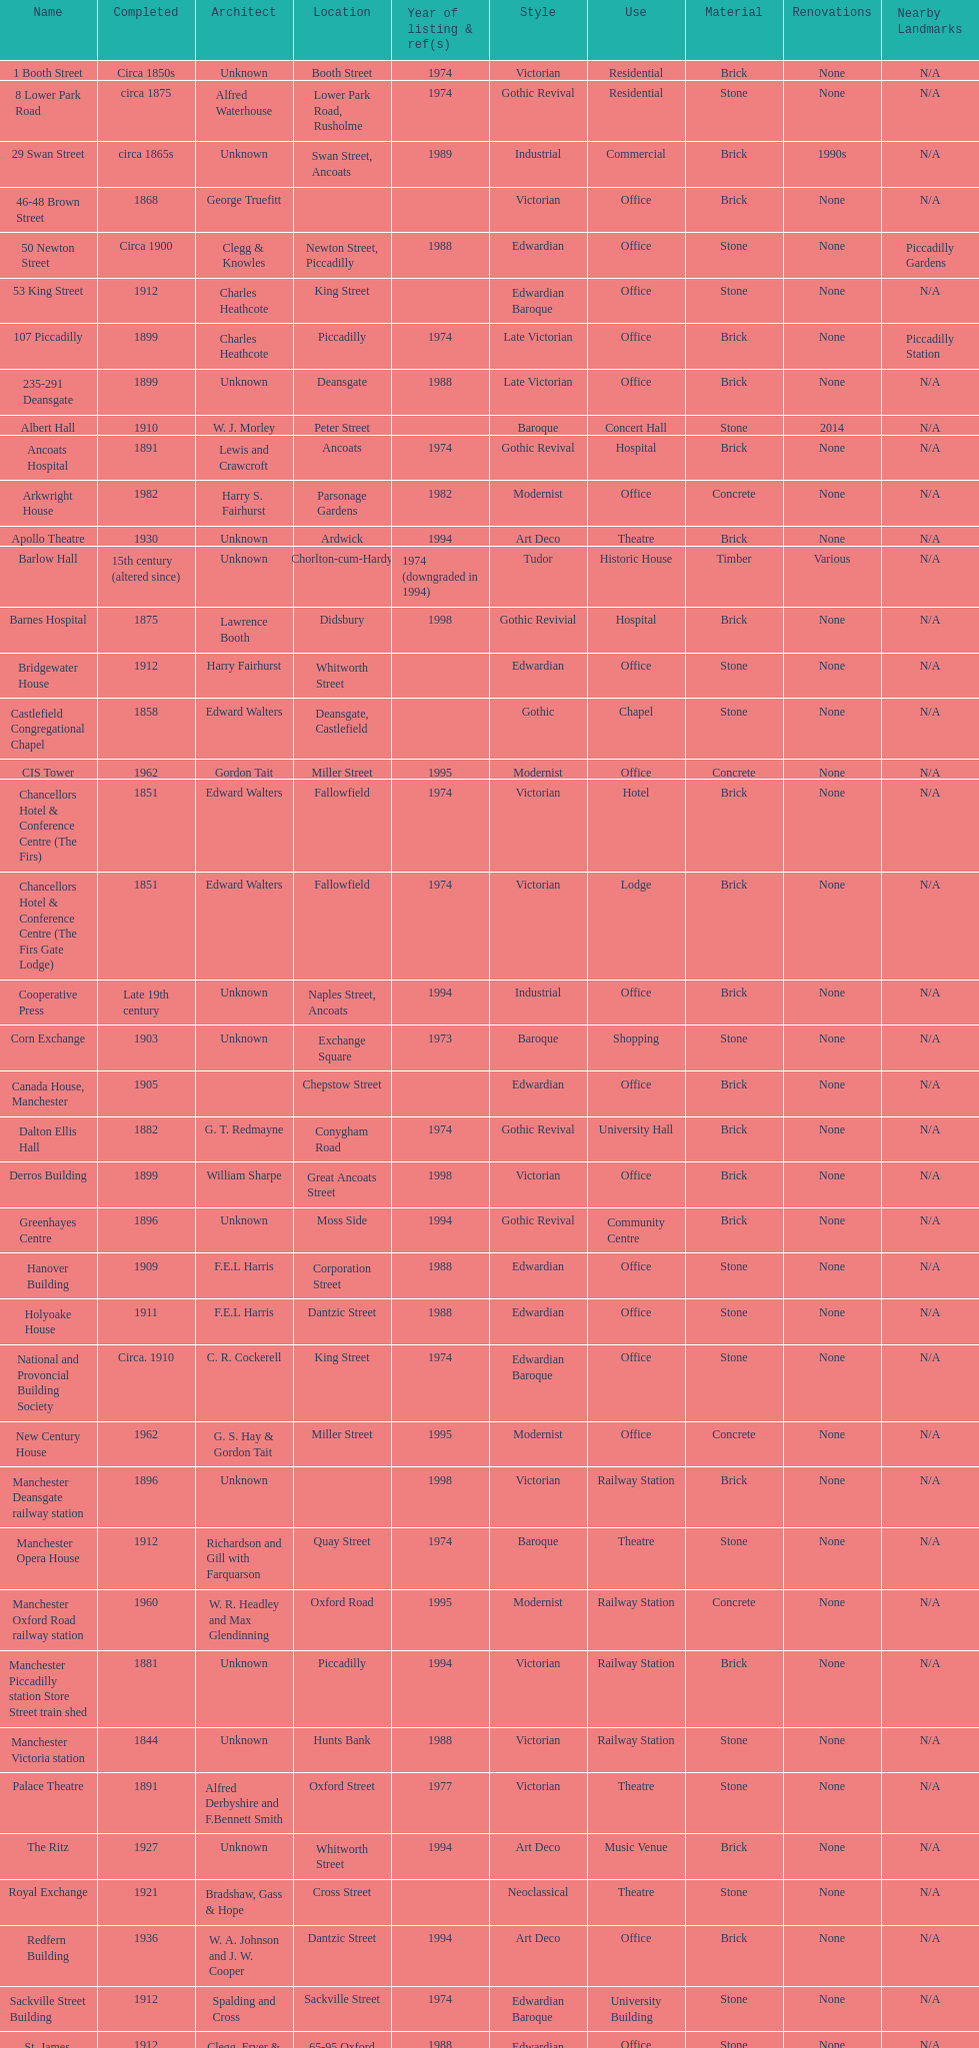How many buildings had alfred waterhouse as their architect? 3. 